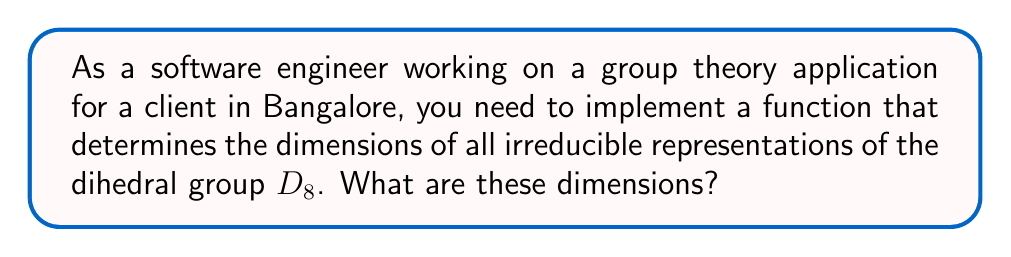Help me with this question. To find the dimensions of all irreducible representations of the dihedral group $D_8$, we'll follow these steps:

1) First, recall that $D_8$ is the symmetry group of a square, with 8 elements: 4 rotations and 4 reflections.

2) The number of irreducible representations is equal to the number of conjugacy classes. Let's determine the conjugacy classes of $D_8$:
   - {e} (identity)
   - {r, r^3} (90° and 270° rotations)
   - {r^2} (180° rotation)
   - {s, sr^2} (reflections across diagonals)
   - {sr, sr^3} (reflections across vertical and horizontal axes)

   There are 5 conjugacy classes, so $D_8$ has 5 irreducible representations.

3) The sum of the squares of the dimensions of irreducible representations equals the order of the group. Let's call the dimensions $d_1, d_2, d_3, d_4, d_5$. Then:

   $$d_1^2 + d_2^2 + d_3^2 + d_4^2 + d_5^2 = |D_8| = 8$$

4) $D_8$ is non-abelian, so not all representations are 1-dimensional. However, every group has at least one 1-dimensional representation (the trivial representation).

5) For dihedral groups, we know that there are always four 1-dimensional representations and the rest are 2-dimensional.

6) Therefore, we have:

   $$1^2 + 1^2 + 1^2 + 1^2 + 2^2 = 8$$

   Which satisfies our equation from step 3.

Thus, the dimensions of the irreducible representations of $D_8$ are 1, 1, 1, 1, and 2.
Answer: 1, 1, 1, 1, 2 